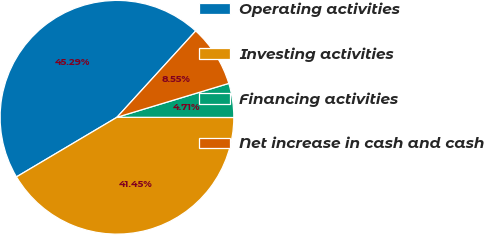Convert chart to OTSL. <chart><loc_0><loc_0><loc_500><loc_500><pie_chart><fcel>Operating activities<fcel>Investing activities<fcel>Financing activities<fcel>Net increase in cash and cash<nl><fcel>45.29%<fcel>41.45%<fcel>4.71%<fcel>8.55%<nl></chart> 